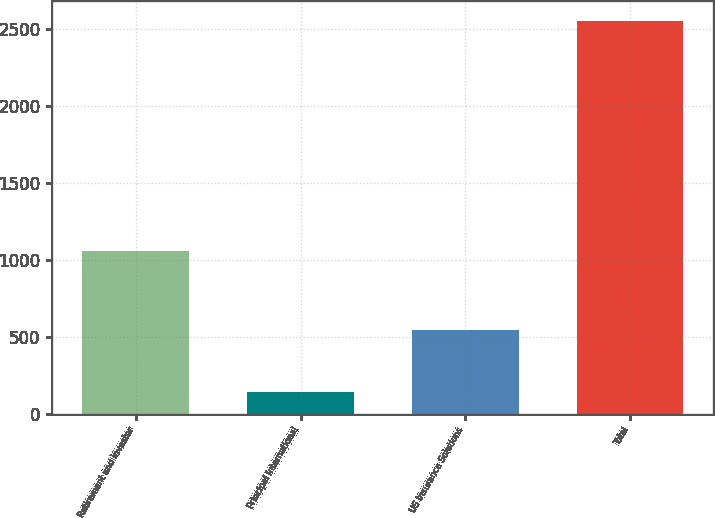<chart> <loc_0><loc_0><loc_500><loc_500><bar_chart><fcel>Retirement and Investor<fcel>Principal International<fcel>US Insurance Solutions<fcel>Total<nl><fcel>1059.1<fcel>139.5<fcel>541.8<fcel>2553.1<nl></chart> 